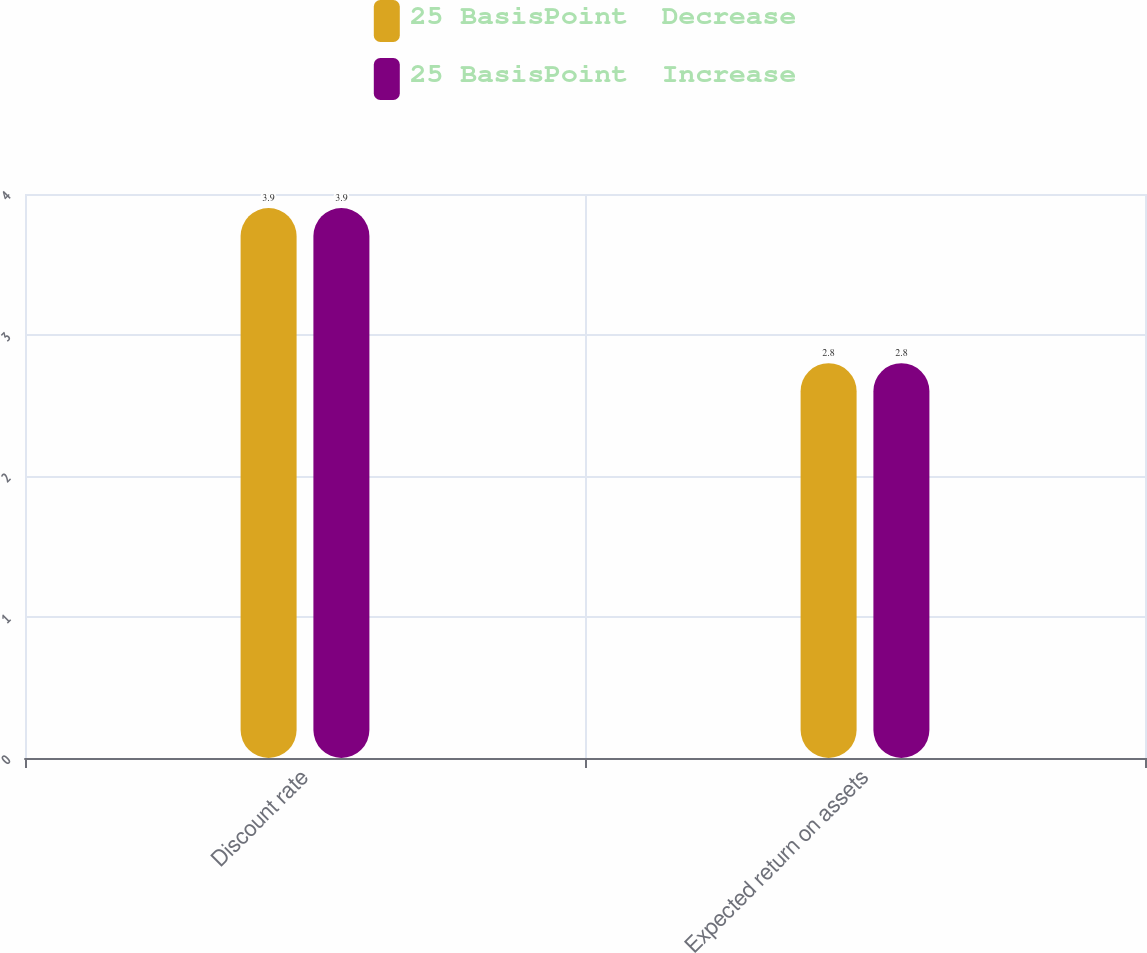<chart> <loc_0><loc_0><loc_500><loc_500><stacked_bar_chart><ecel><fcel>Discount rate<fcel>Expected return on assets<nl><fcel>25 BasisPoint  Decrease<fcel>3.9<fcel>2.8<nl><fcel>25 BasisPoint  Increase<fcel>3.9<fcel>2.8<nl></chart> 